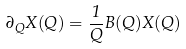Convert formula to latex. <formula><loc_0><loc_0><loc_500><loc_500>\partial _ { Q } X ( Q ) = \frac { 1 } { Q } B ( Q ) X ( Q )</formula> 